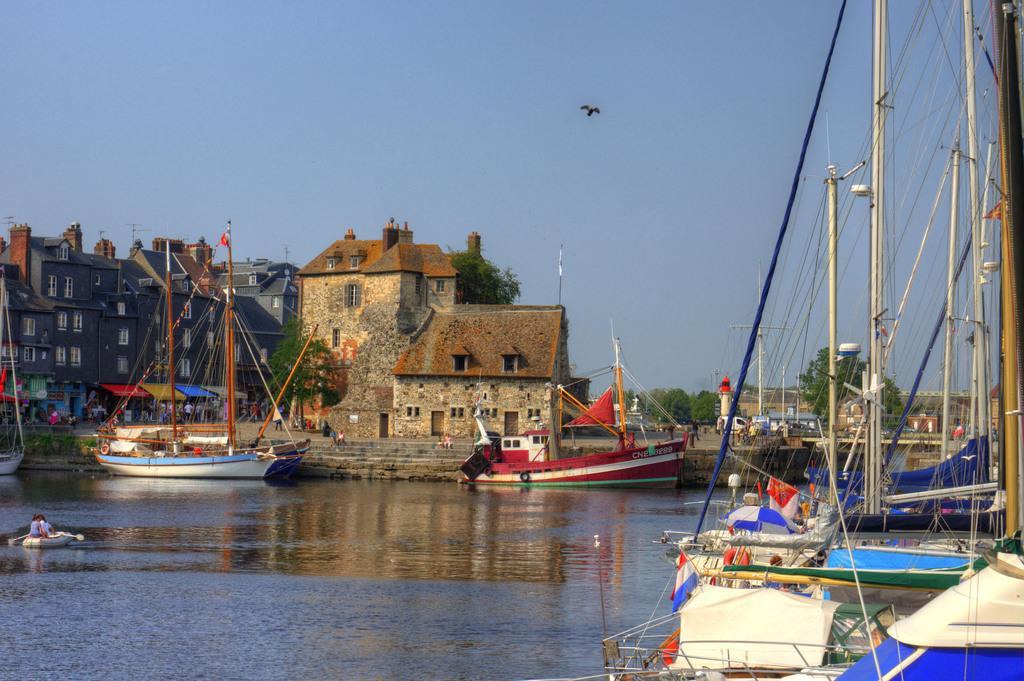Please provide a concise description of this image. In this image we can see many boats floating on the water. Here we can see ropes, poles, stone house, buildings, steps, tents, people walking here, a bird flying in the air, trees and the sky in the background. 